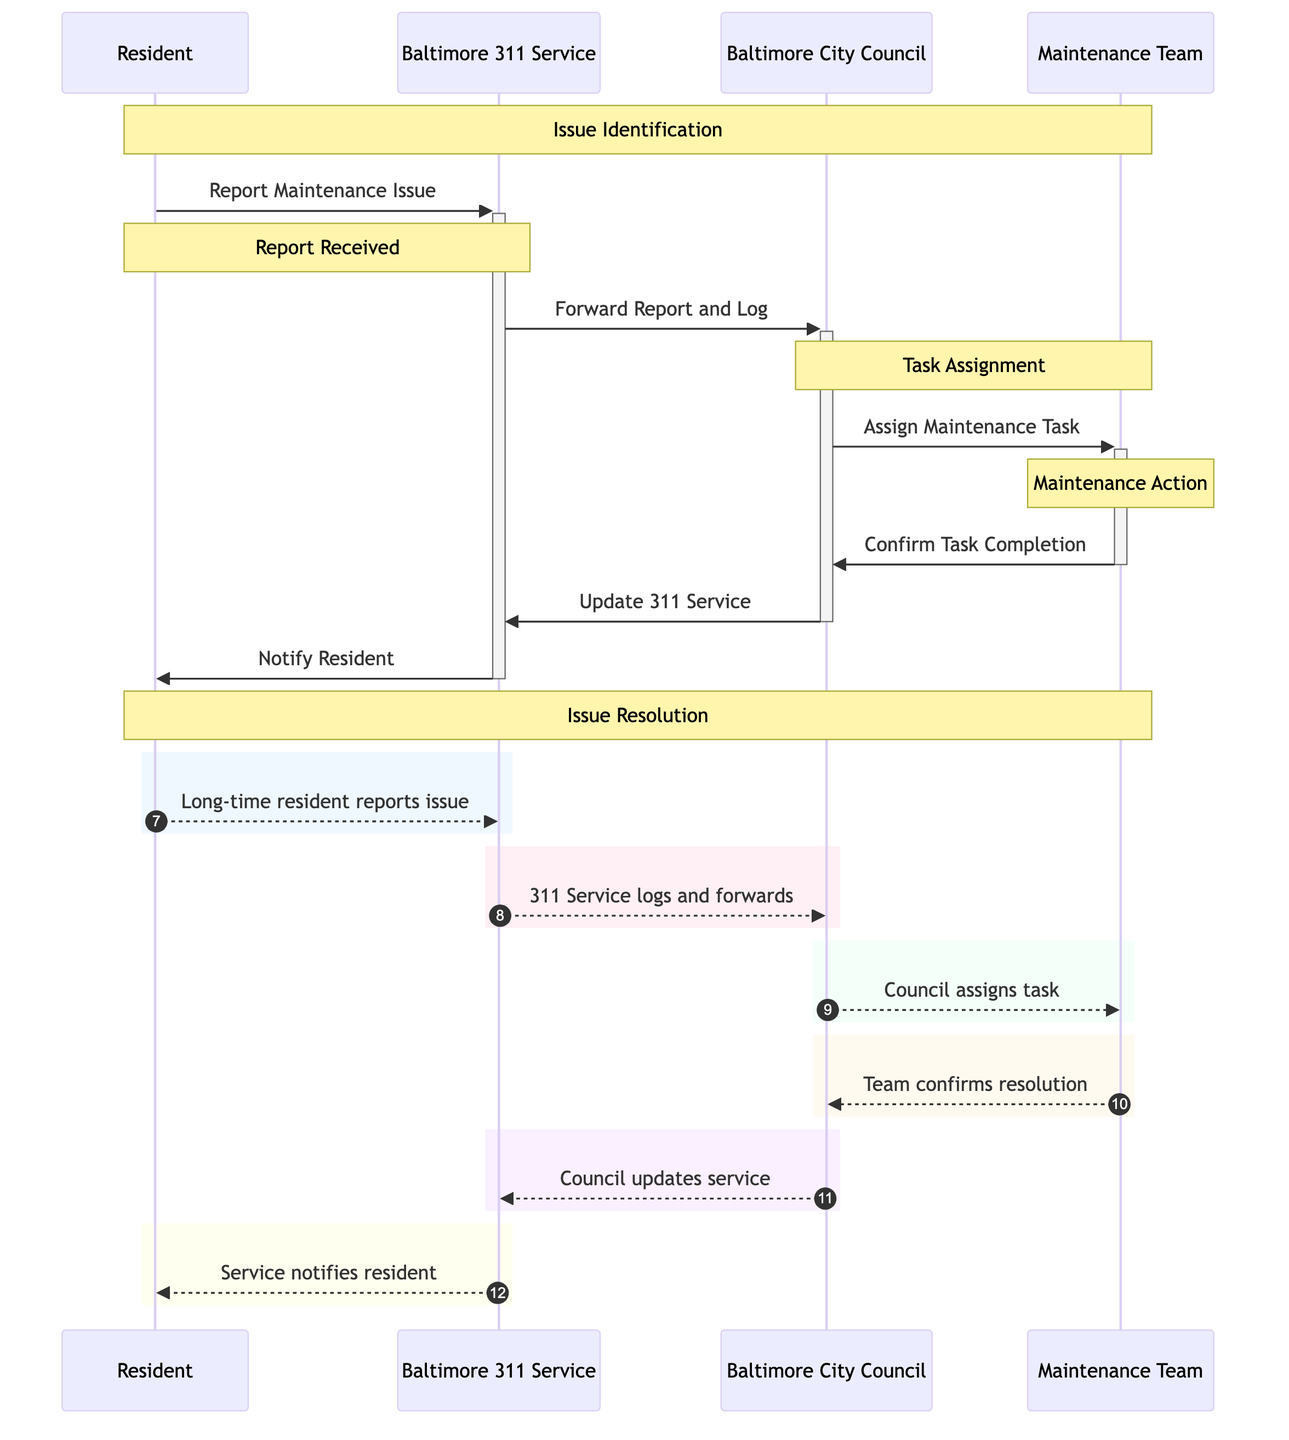what is the first action taken in the sequence diagram? The first action in the sequence diagram is the Resident reporting a maintenance issue to the Baltimore 311 Service. This is indicated by the arrow from Resident to Baltimore 311 Service labeled "Report Maintenance Issue."
Answer: Report Maintenance Issue how many actors are involved in this sequence diagram? There are four actors involved in the sequence diagram: Resident, Baltimore City Council, Baltimore 311 Service, and Maintenance Team. Each is represented as a participant in the diagram.
Answer: Four what action does the Baltimore City Council perform after receiving the report? After receiving the report from the Baltimore 311 Service, the Baltimore City Council assigns the maintenance task to the Maintenance Team, as represented by the message "Assign Maintenance Task."
Answer: Assign Maintenance Task what happens after the Maintenance Team confirms task completion? After the Maintenance Team confirms task completion, the Baltimore City Council updates the Baltimore 311 Service on the resolution status, which is depicted by the message "Update 311 Service."
Answer: Update 311 Service how many steps are there from issue identification to resolution notification? There are five distinct steps from issue identification to resolution notification, which include: Resident identifies an issue, 311 Service receives the report, City Council assigns the task, Maintenance Team completes the task, and 311 Service notifies the Resident.
Answer: Five which actor is responsible for notifying the Resident? The Baltimore 311 Service is responsible for notifying the Resident after the issue has been resolved, as shown by the message "Notify Resident."
Answer: Baltimore 311 Service what is the role of Baltimore 311 Service in this sequence? The role of Baltimore 311 Service includes receiving the maintenance issue report from the Resident, forwarding it to the City Council, and later notifying the Resident about the resolution.
Answer: Forwarding and notifying in what order do the tasks occur after an issue is reported? The order of tasks after an issue is reported is: the Resident reports the issue, the 311 Service logs and forwards the report to the City Council, the City Council assigns the maintenance task to the Maintenance Team, the Maintenance Team confirms task completion, and finally, the council updates the 311 Service.
Answer: Sequential order from reporting to updating what type of messages are used in the diagram? The messages in the diagram are action-based messages that describe the activities between actors, including reporting, forwarding, assigning, confirming, updating, and notifying.
Answer: Action-based messages 